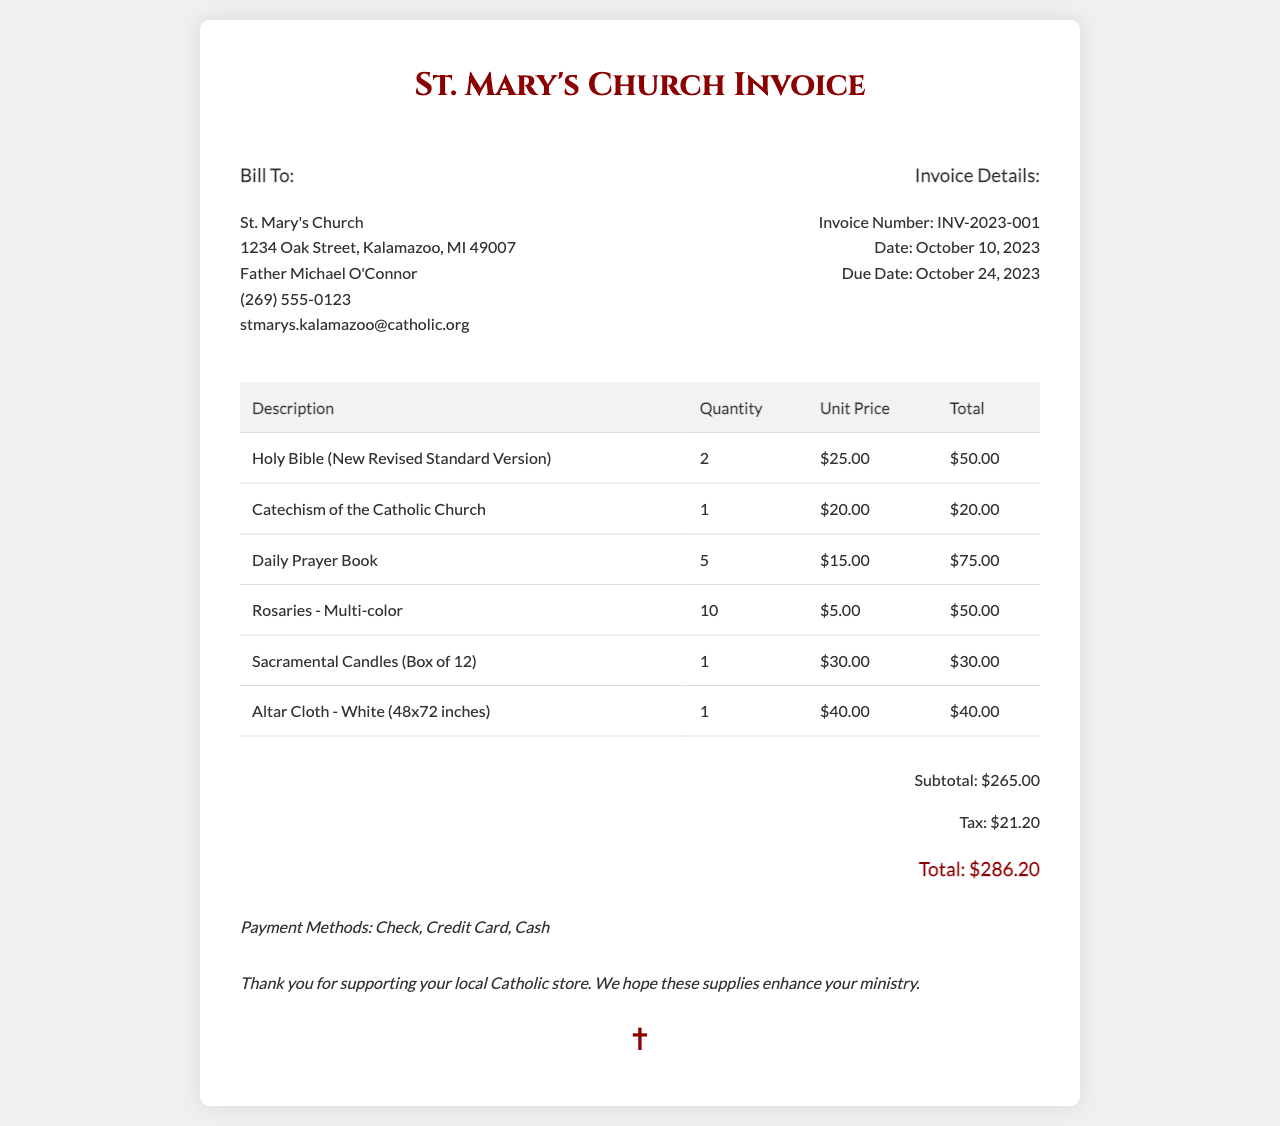What is the invoice number? The invoice number is clearly mentioned in the document and is labeled as "Invoice Number."
Answer: INV-2023-001 Who is the billed party? The billed party is specified in the "Bill To" section of the document.
Answer: St. Mary's Church What is the total amount due? The total amount is presented at the bottom of the invoice under the "Total" section.
Answer: $286.20 How many Holy Bibles were purchased? The quantity of Holy Bibles is listed in the table for that item.
Answer: 2 What is the due date for the invoice? The due date is specified in the invoice details section.
Answer: October 24, 2023 What payment methods are accepted? The accepted payment methods are listed towards the end of the document.
Answer: Check, Credit Card, Cash What item has the highest unit price? The highest unit price can be found by comparing the unit prices in the invoice table.
Answer: Holy Bible (New Revised Standard Version) How many items in total were purchased? The total can be calculated by summing up the quantities listed for each item in the invoice.
Answer: 19 